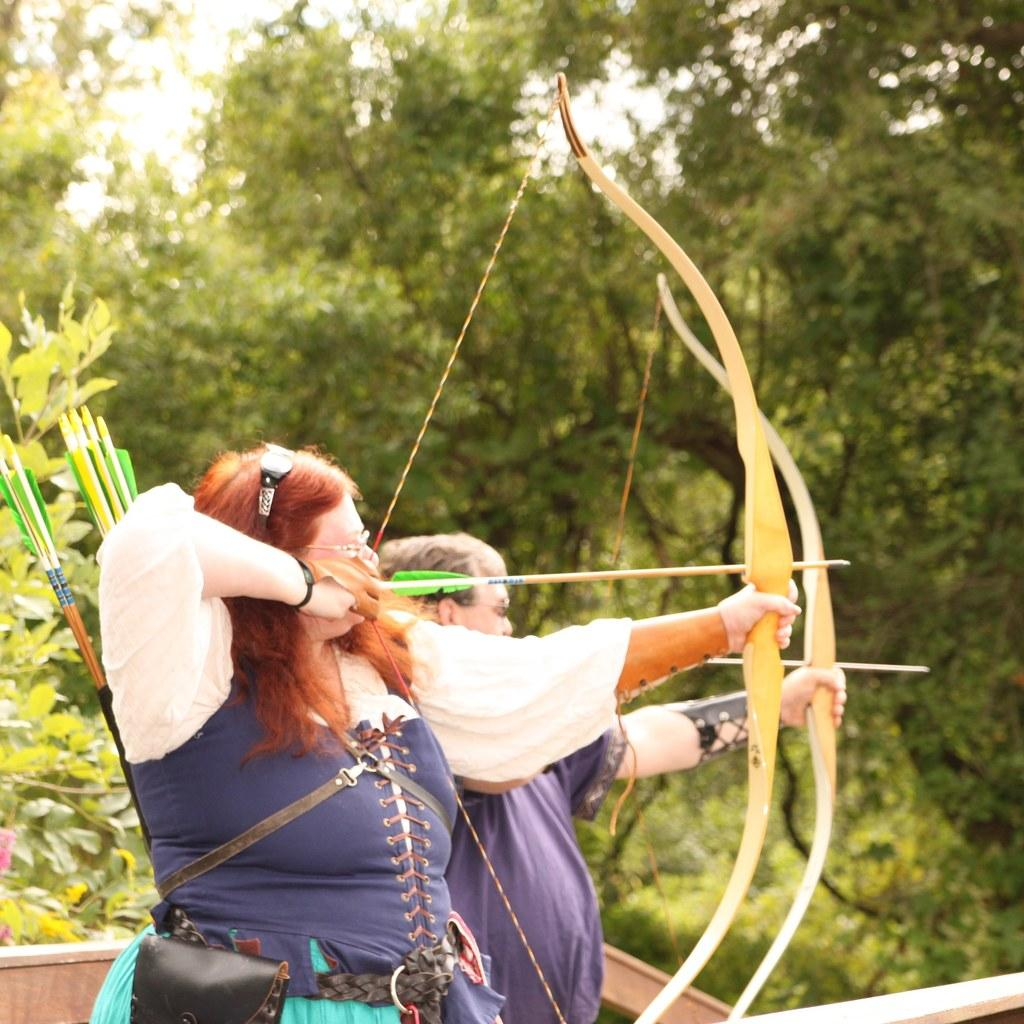How many people are in the image? There are two people in the image. What are the people holding in the image? The people are holding arrows and bows in the image. What can be seen in the background of the image? There are trees in the background of the image. What type of bead is being used to decorate the arrows in the image? There are no beads present on the arrows in the image; they are simply holding arrows and bows. 